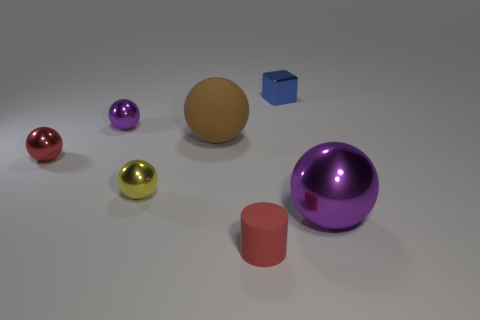Add 2 brown metallic blocks. How many objects exist? 9 Subtract all big purple balls. How many balls are left? 4 Subtract 4 balls. How many balls are left? 1 Add 1 matte spheres. How many matte spheres are left? 2 Add 7 small purple metal balls. How many small purple metal balls exist? 8 Subtract all yellow balls. How many balls are left? 4 Subtract 0 green cubes. How many objects are left? 7 Subtract all cylinders. How many objects are left? 6 Subtract all yellow spheres. Subtract all gray cubes. How many spheres are left? 4 Subtract all cyan blocks. How many blue cylinders are left? 0 